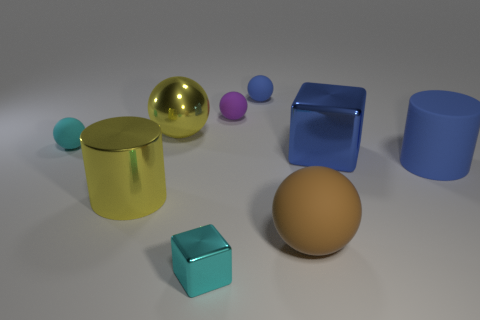Which objects in this image appear to have a reflective surface? The objects with reflective surfaces in this image are the gold ball and the two cylinders, one green and the other blue. These objects display highlights and reflections that indicate a glossy, possibly metallic texture. 